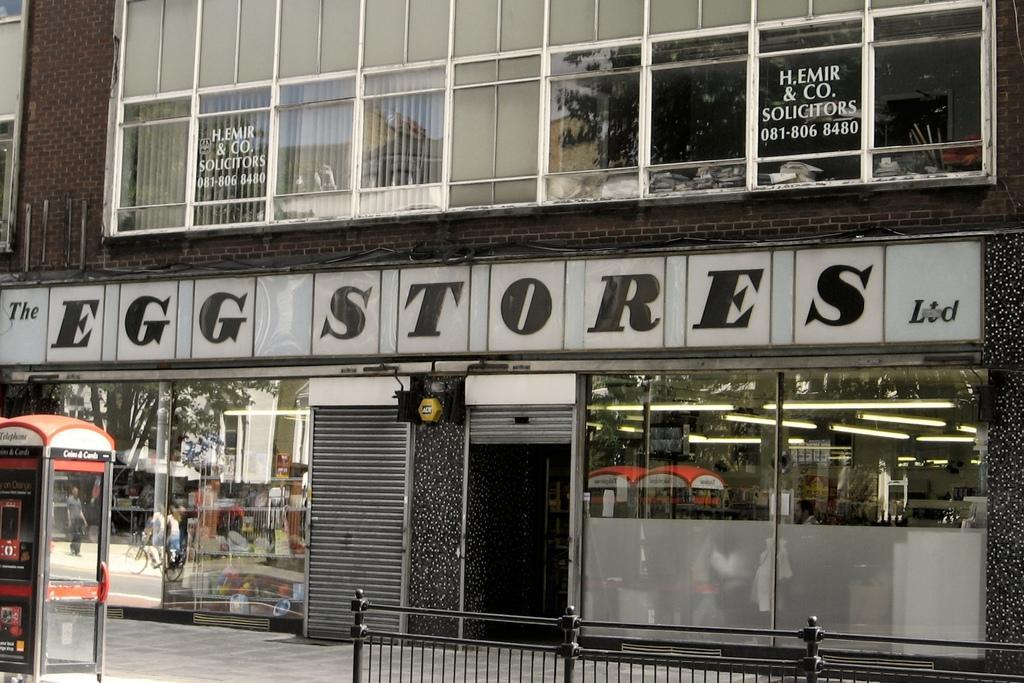How would you summarize this image in a sentence or two? In this image we can see the front view of the glass building. We can also see the windows and also the store and shutter. On the left we can see some booth with the text. At the bottom we can see the fence and also the path. 